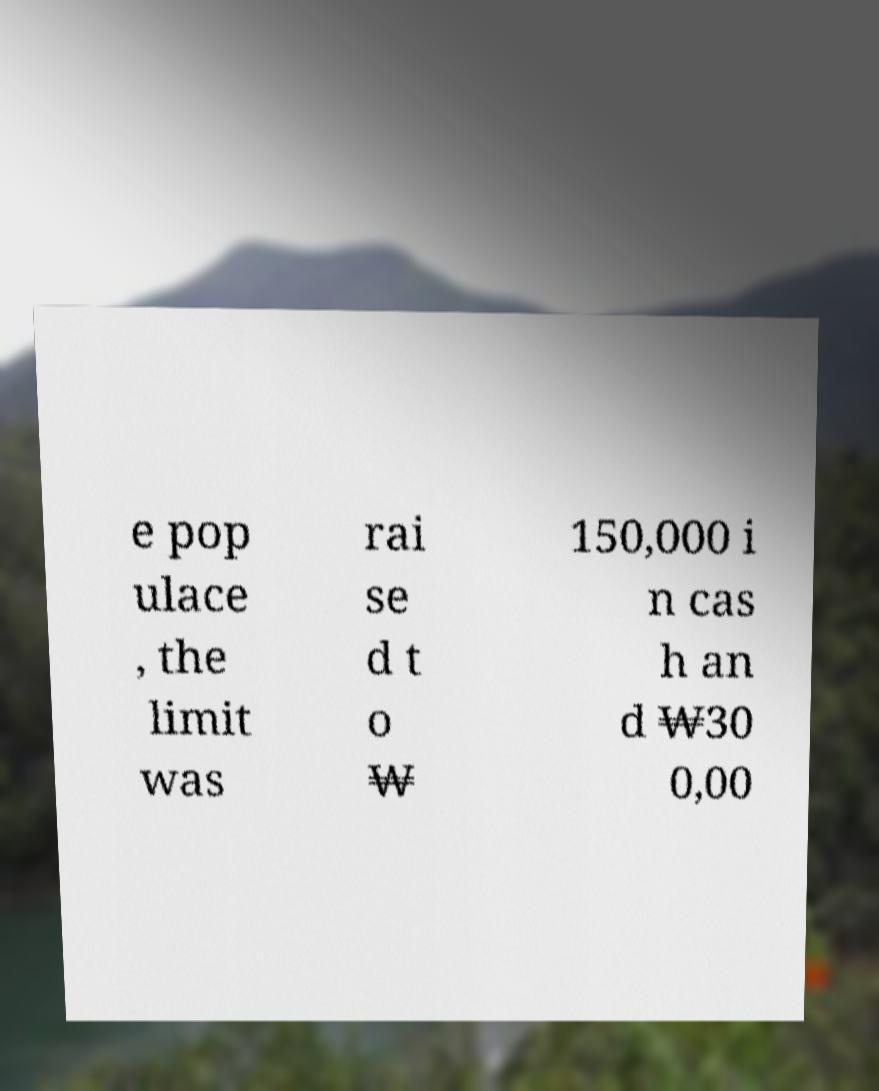There's text embedded in this image that I need extracted. Can you transcribe it verbatim? e pop ulace , the limit was rai se d t o ₩ 150,000 i n cas h an d ₩30 0,00 